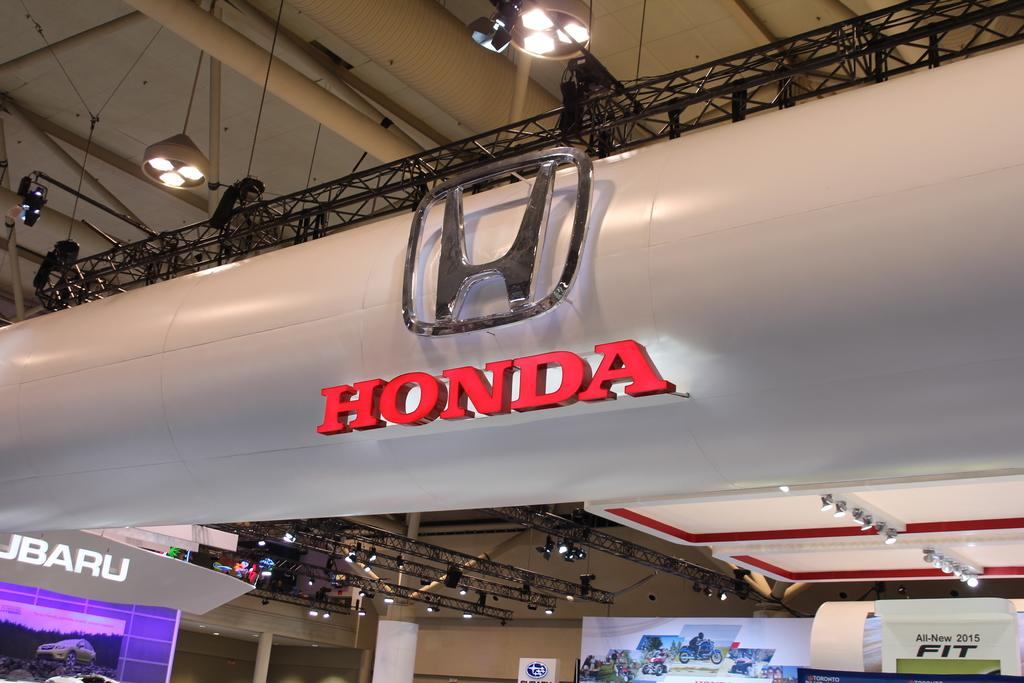<image>
Write a terse but informative summary of the picture. A large Honda sign hangs above a Subaru sign. 